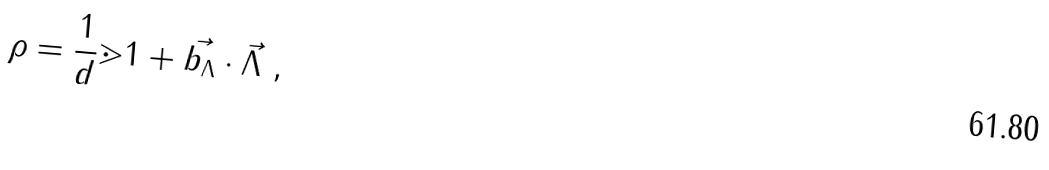Convert formula to latex. <formula><loc_0><loc_0><loc_500><loc_500>\rho = \frac { 1 } { d } \mathbb { m } { 1 } + \vec { b _ { \Lambda } } \cdot \vec { \Lambda } \ ,</formula> 